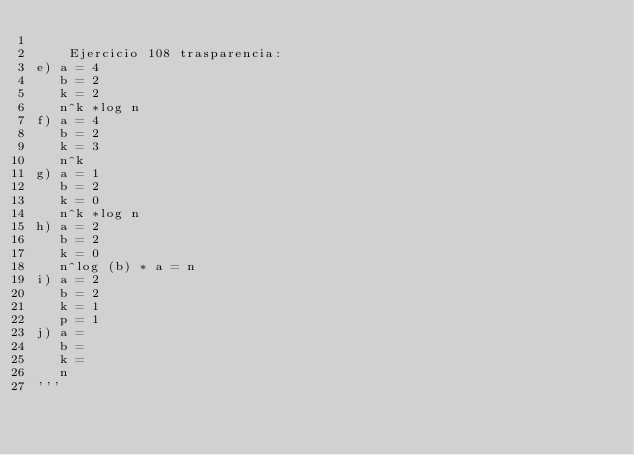Convert code to text. <code><loc_0><loc_0><loc_500><loc_500><_Python_>
    Ejercicio 108 trasparencia:
e) a = 4
   b = 2
   k = 2
   n^k *log n
f) a = 4
   b = 2
   k = 3
   n^k
g) a = 1
   b = 2
   k = 0
   n^k *log n
h) a = 2
   b = 2
   k = 0
   n^log (b) * a = n
i) a = 2
   b = 2
   k = 1
   p = 1
j) a =
   b =
   k =
   n
'''
</code> 